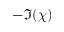<formula> <loc_0><loc_0><loc_500><loc_500>- \Im ( \chi )</formula> 